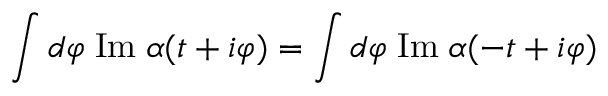<formula> <loc_0><loc_0><loc_500><loc_500>\int d \varphi \, I m \, \alpha ( t + i \varphi ) = \int d \varphi \, I m \, \alpha ( - t + i \varphi )</formula> 